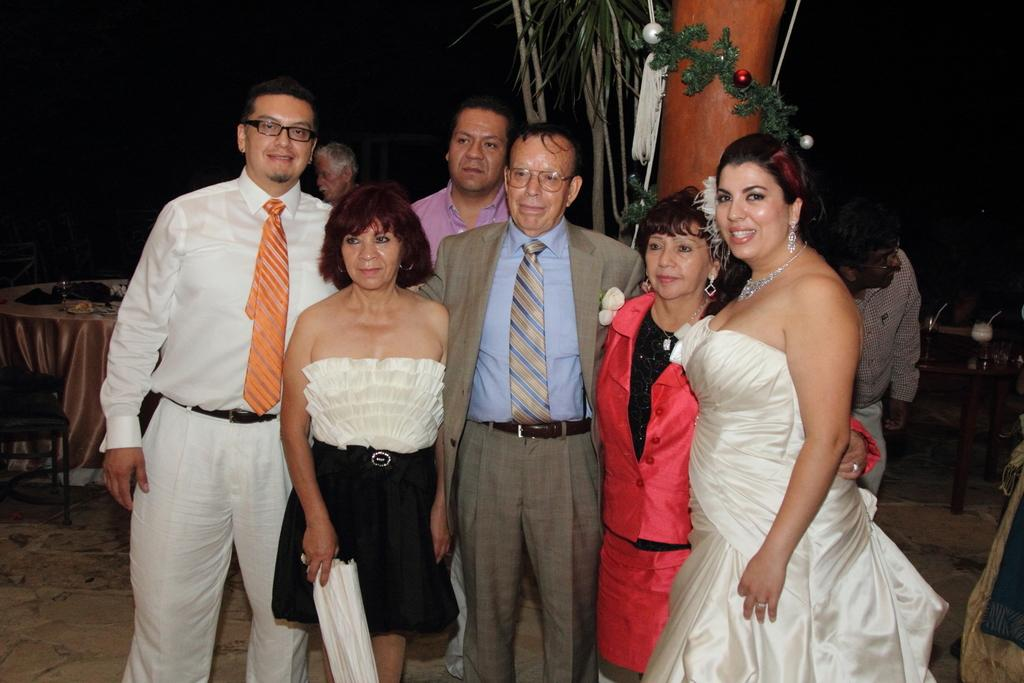How many people are in the image? There is a group of people in the image, but the exact number is not specified. Where are the people standing in the image? The people are standing on a path in the image. What other structures can be seen in the image? There is a pillar in the image. What type of vegetation is present in the image? There are trees in the image. What type of furniture is in the image? There is a table and chairs in the image. What can be observed about the background behind the pillar? The background behind the pillar is dark. How many kittens are playing on the table in the image? There are no kittens present in the image; it only features a group of people, a path, a pillar, trees, a table, and chairs. 